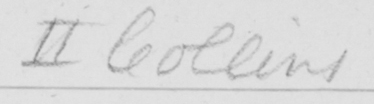Transcribe the text shown in this historical manuscript line. II Collins 